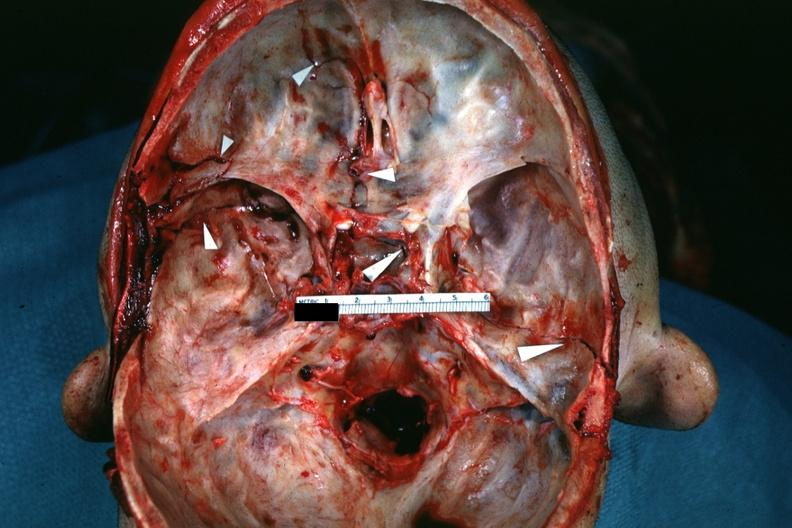s fractures brain which is slide and close-up view of these fractures slide?
Answer the question using a single word or phrase. Yes 